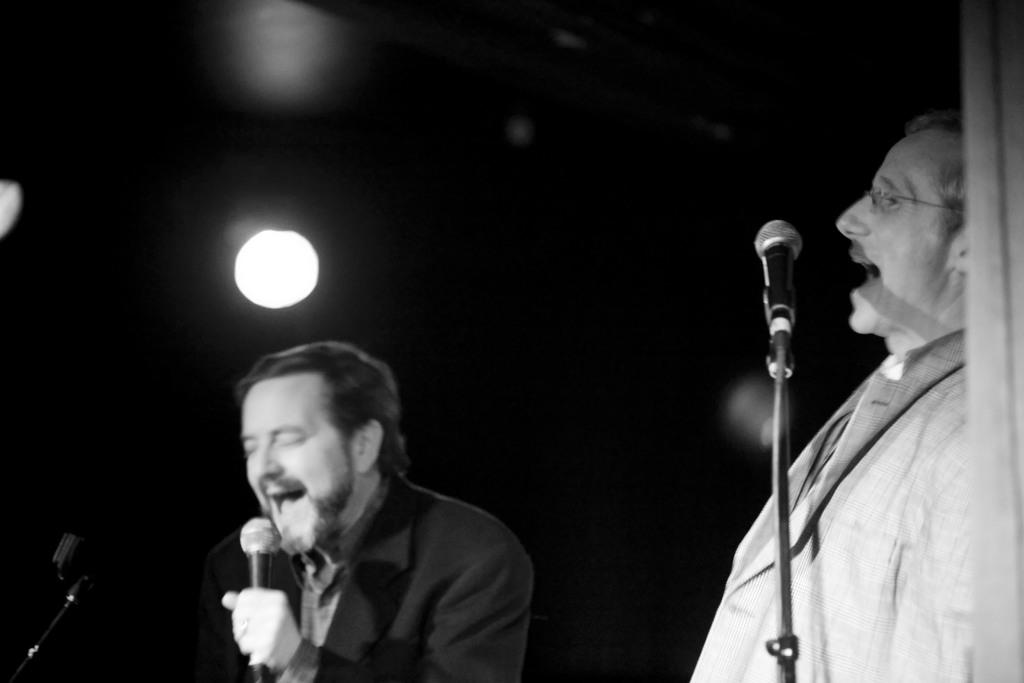How many people are in the image? There are two men in the image. What are the men wearing? One of the men is wearing a blazer, and one of the men is wearing spectacles. What are the men doing in the image? Both men are singing on microphones. What can be seen in the background of the image? There is lighting visible in the background, and the background appears to be dark. Can you hear the sound of thunder in the image? There is no sound present in the image, so it is not possible to determine if there is thunder or any other sound. 